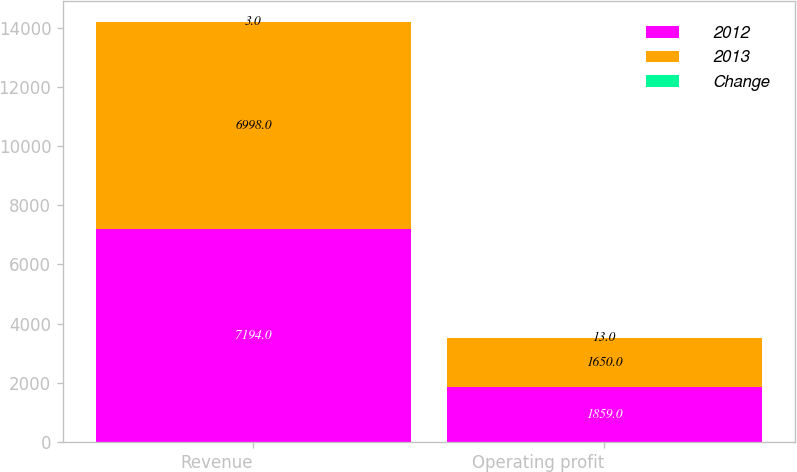Convert chart. <chart><loc_0><loc_0><loc_500><loc_500><stacked_bar_chart><ecel><fcel>Revenue<fcel>Operating profit<nl><fcel>2012<fcel>7194<fcel>1859<nl><fcel>2013<fcel>6998<fcel>1650<nl><fcel>Change<fcel>3<fcel>13<nl></chart> 